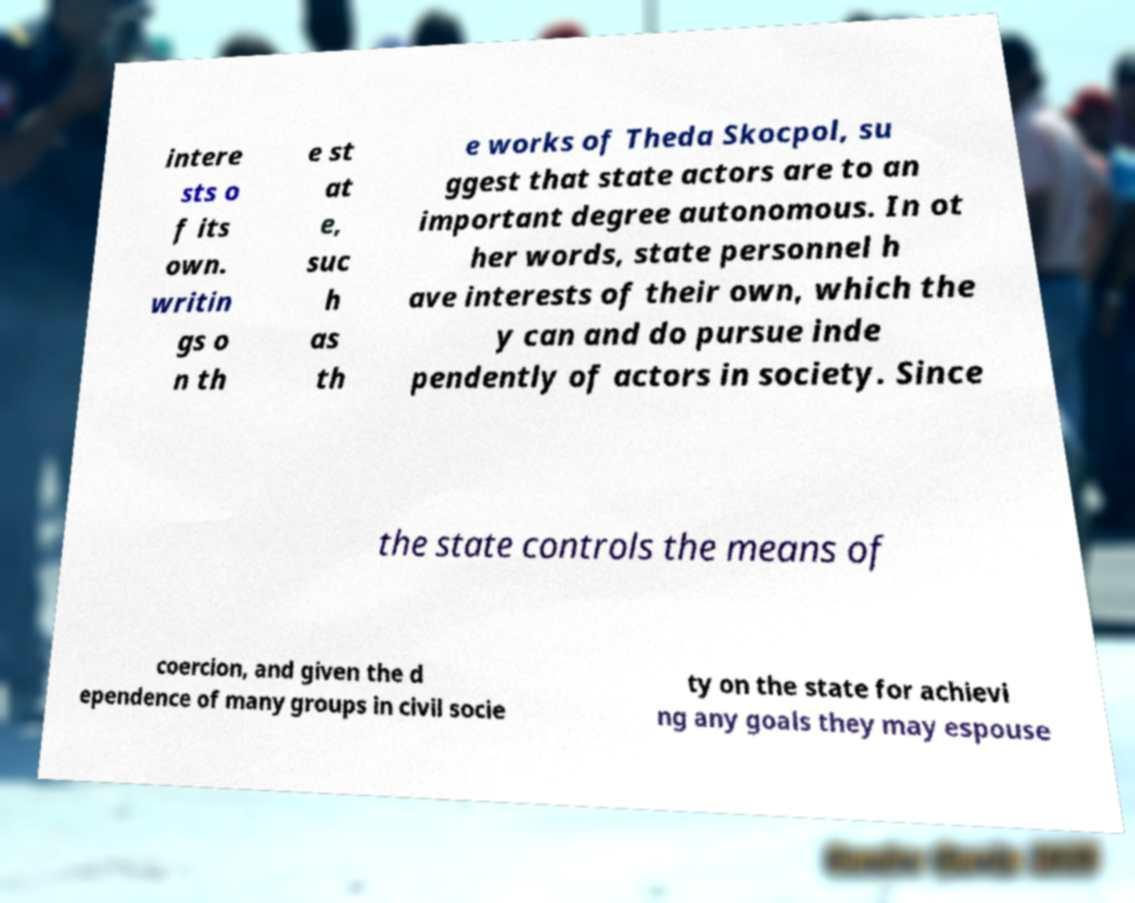Can you accurately transcribe the text from the provided image for me? intere sts o f its own. writin gs o n th e st at e, suc h as th e works of Theda Skocpol, su ggest that state actors are to an important degree autonomous. In ot her words, state personnel h ave interests of their own, which the y can and do pursue inde pendently of actors in society. Since the state controls the means of coercion, and given the d ependence of many groups in civil socie ty on the state for achievi ng any goals they may espouse 